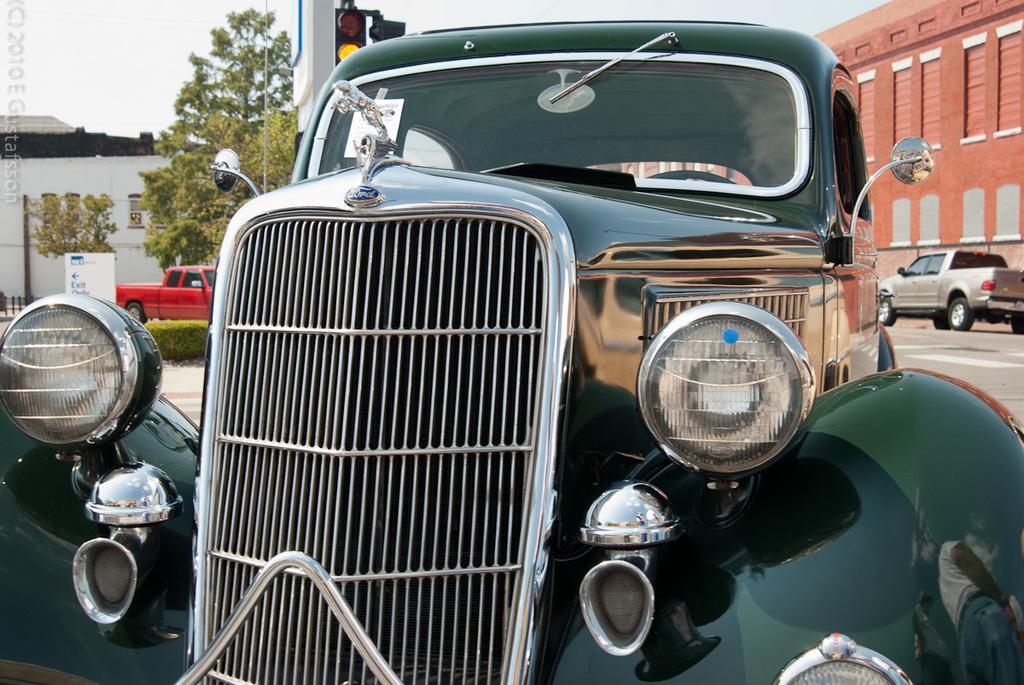In one or two sentences, can you explain what this image depicts? In the background we can see a sky, a house and trees. At the right side of the picture we can see a wall. We can see vehicles on the road. This is a board in white color and there is something written on it. This is a traffic signal. 